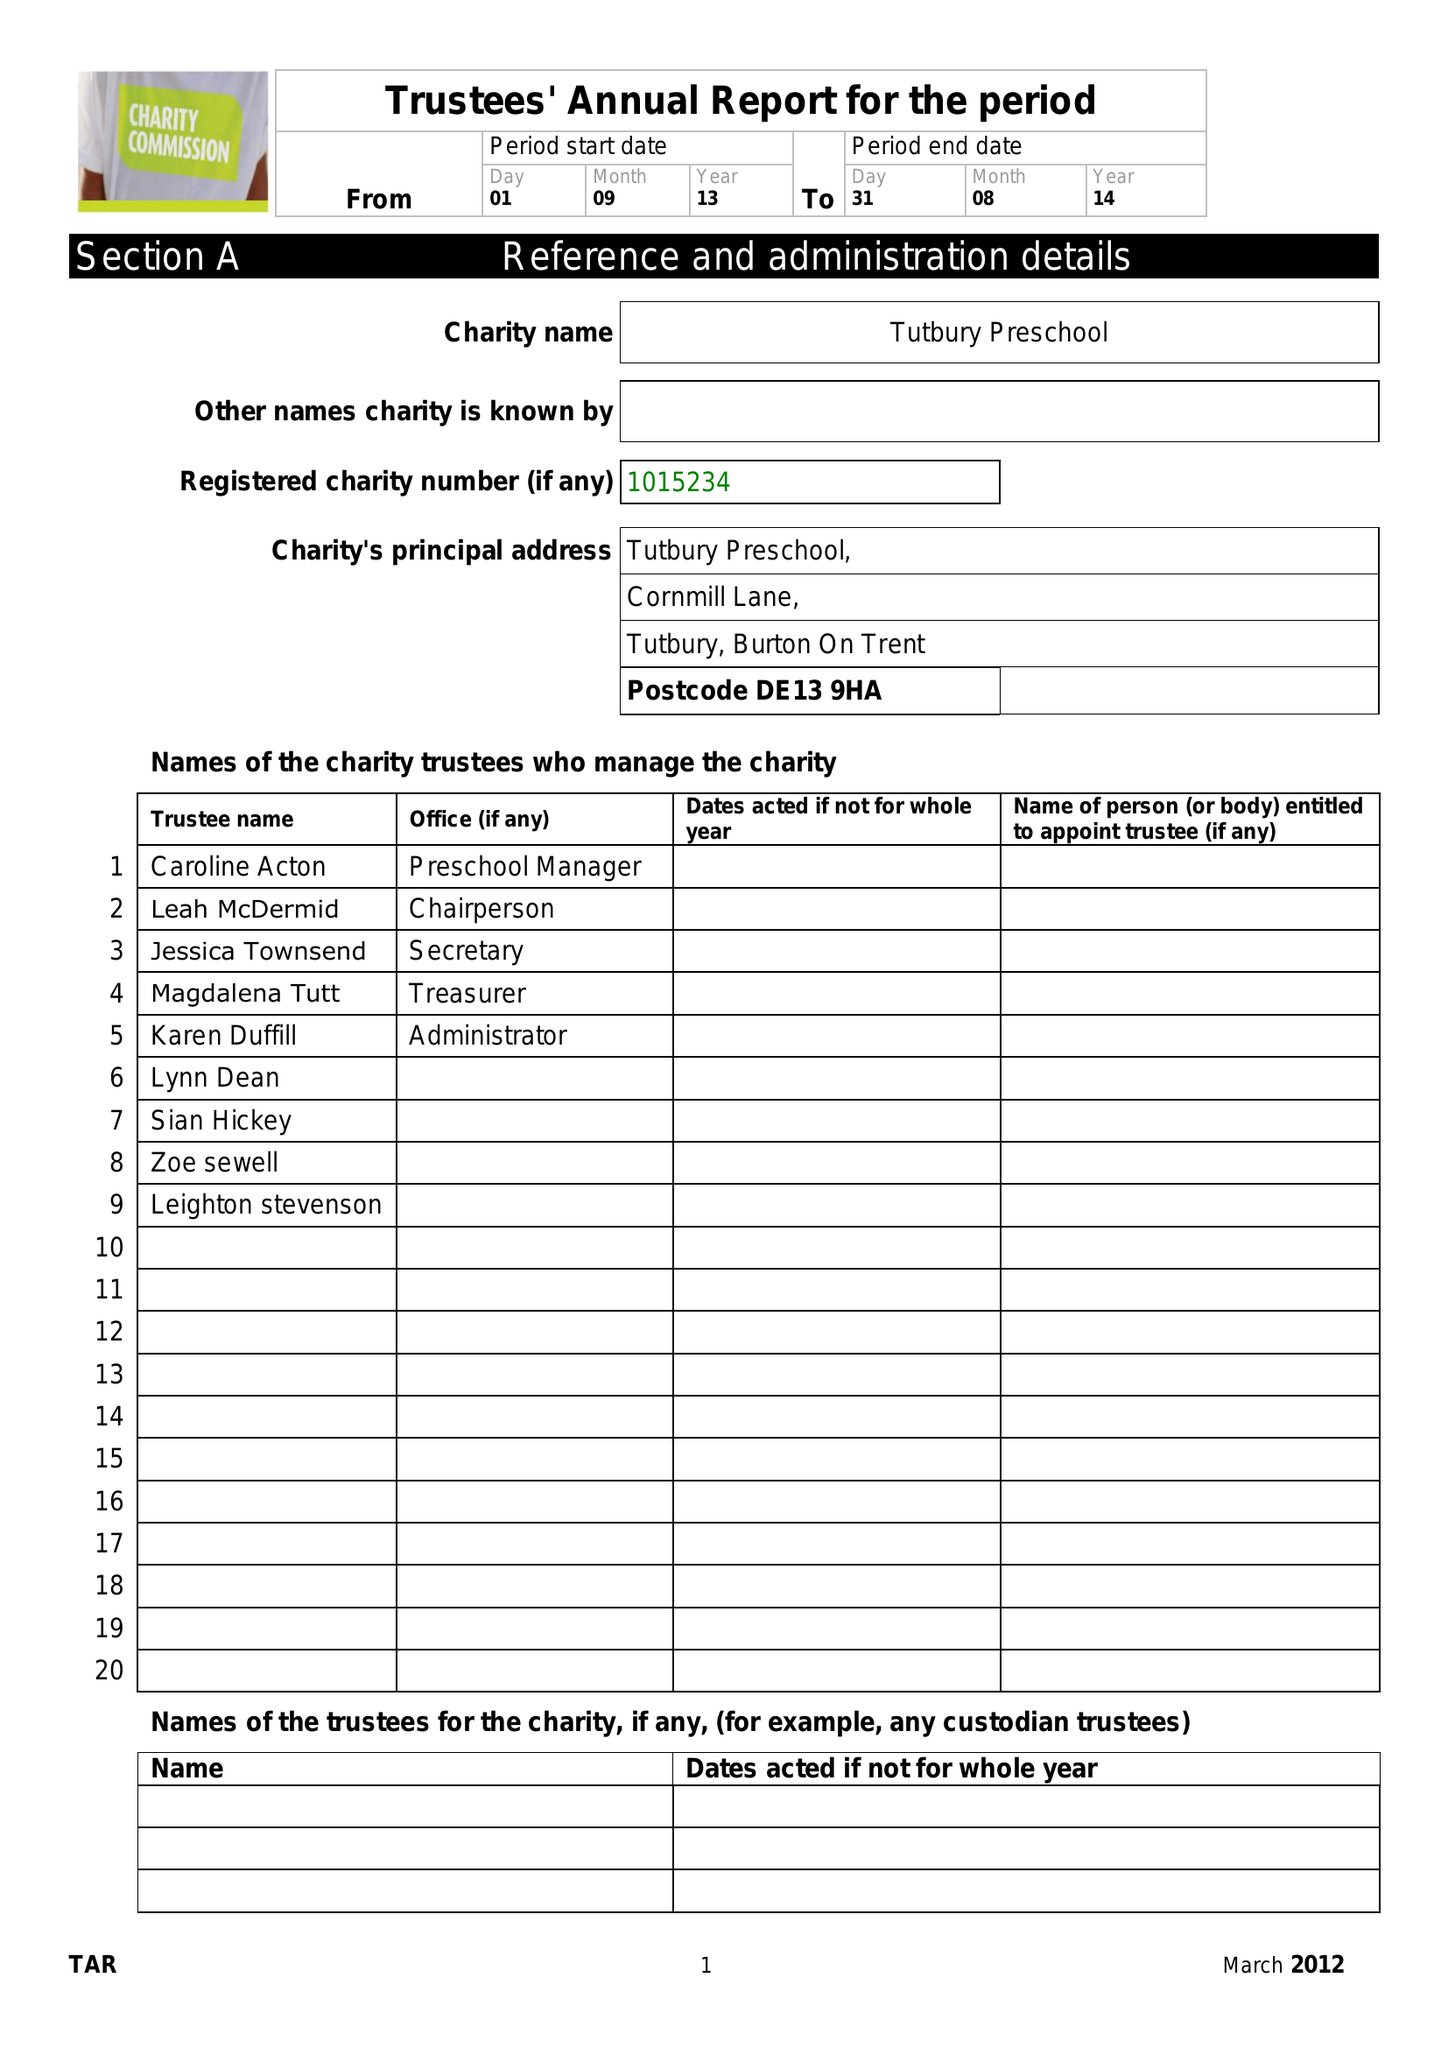What is the value for the address__street_line?
Answer the question using a single word or phrase. 170 ROLLESTON ROAD 